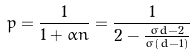Convert formula to latex. <formula><loc_0><loc_0><loc_500><loc_500>p = \frac { 1 } { 1 + \alpha n } = \frac { 1 } { 2 - \frac { \sigma d - 2 } { \sigma ( d - 1 ) } }</formula> 